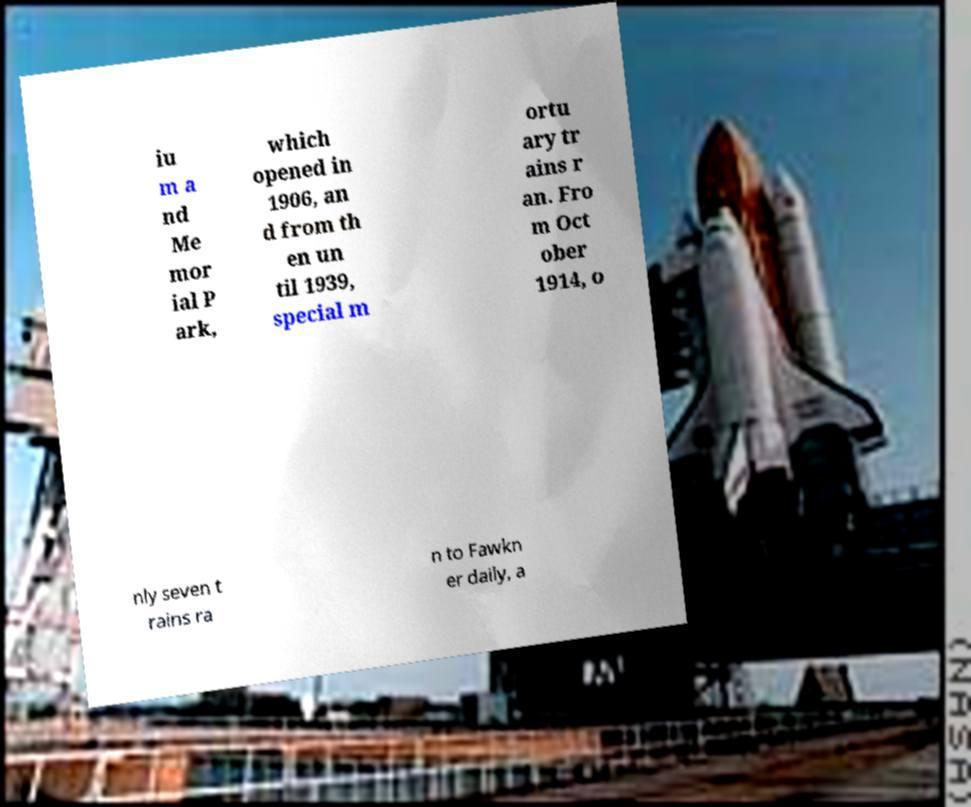Please read and relay the text visible in this image. What does it say? iu m a nd Me mor ial P ark, which opened in 1906, an d from th en un til 1939, special m ortu ary tr ains r an. Fro m Oct ober 1914, o nly seven t rains ra n to Fawkn er daily, a 